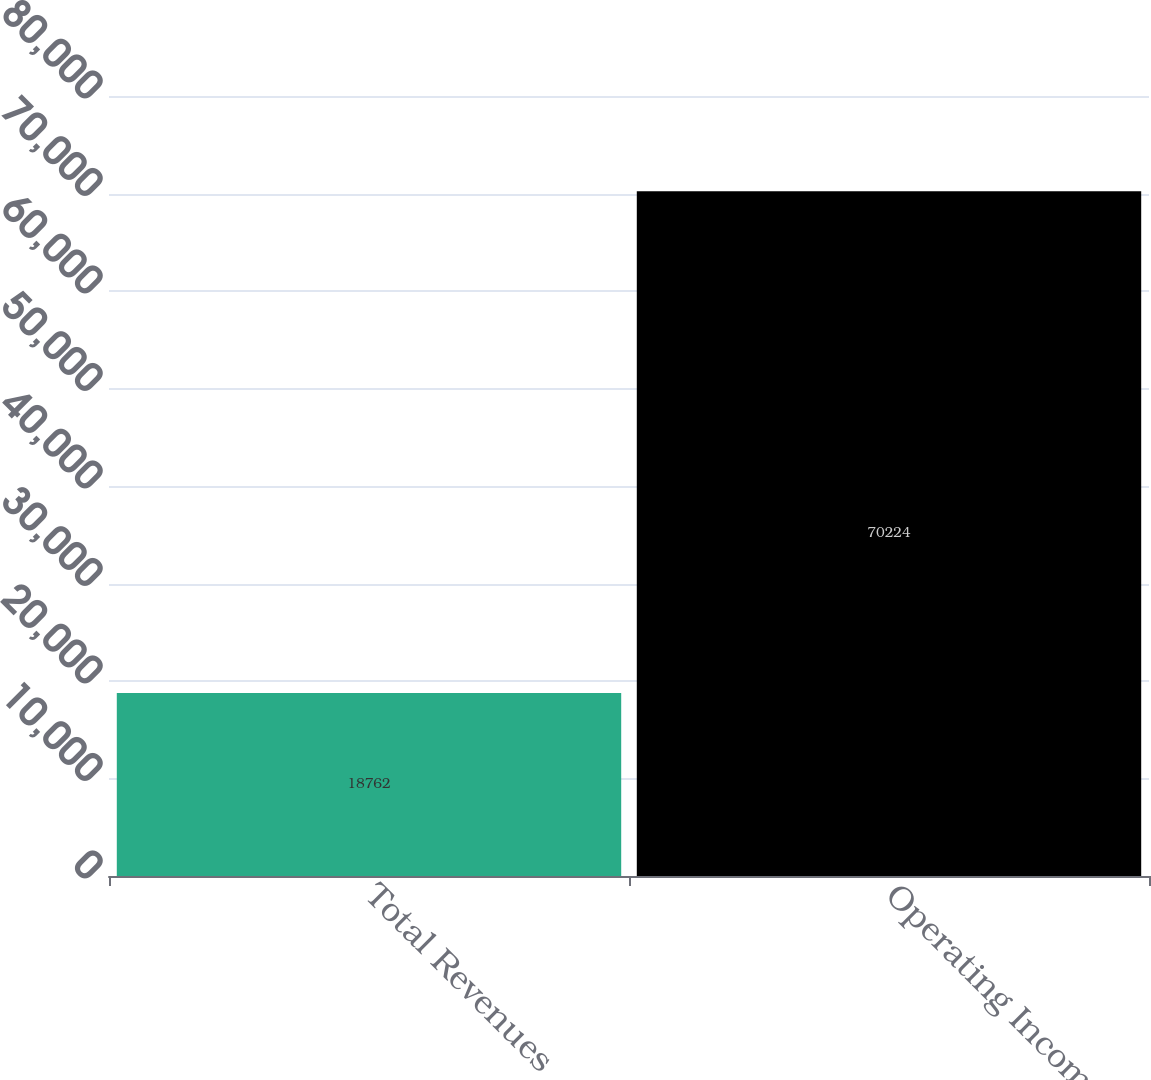Convert chart. <chart><loc_0><loc_0><loc_500><loc_500><bar_chart><fcel>Total Revenues<fcel>Operating Income<nl><fcel>18762<fcel>70224<nl></chart> 